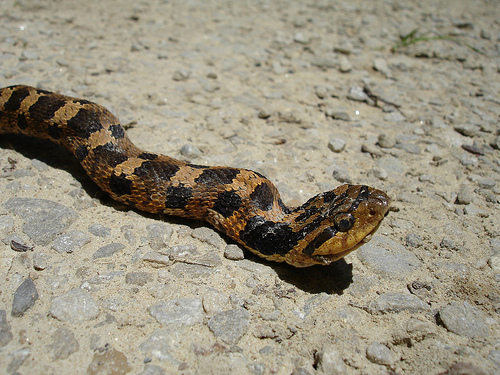<image>
Can you confirm if the snake is on the land? Yes. Looking at the image, I can see the snake is positioned on top of the land, with the land providing support. Where is the snack in relation to the floor? Is it on the floor? Yes. Looking at the image, I can see the snack is positioned on top of the floor, with the floor providing support. Is there a snake in front of the looking? No. The snake is not in front of the looking. The spatial positioning shows a different relationship between these objects. 